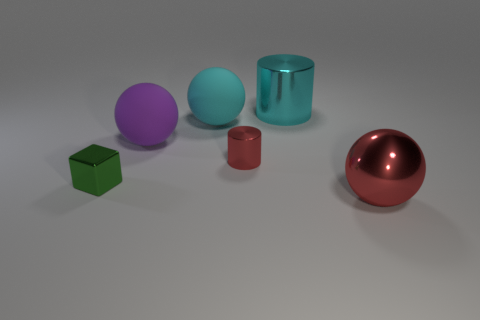What is the size of the green shiny object?
Offer a terse response. Small. Do the big thing in front of the purple sphere and the cyan ball have the same material?
Your response must be concise. No. What number of large rubber cubes are there?
Make the answer very short. 0. How many things are either large purple balls or big matte cylinders?
Your answer should be compact. 1. There is a big thing that is in front of the block on the left side of the big cyan metal thing; what number of big purple balls are left of it?
Ensure brevity in your answer.  1. Is there anything else of the same color as the block?
Make the answer very short. No. Does the large metal object behind the red metallic sphere have the same color as the small object on the left side of the small metallic cylinder?
Offer a terse response. No. Are there more big objects that are right of the big red ball than cyan cylinders to the left of the tiny shiny cylinder?
Give a very brief answer. No. What material is the small red cylinder?
Your answer should be very brief. Metal. There is a red thing on the left side of the big shiny thing that is on the right side of the large cyan cylinder that is behind the big red sphere; what shape is it?
Provide a succinct answer. Cylinder. 